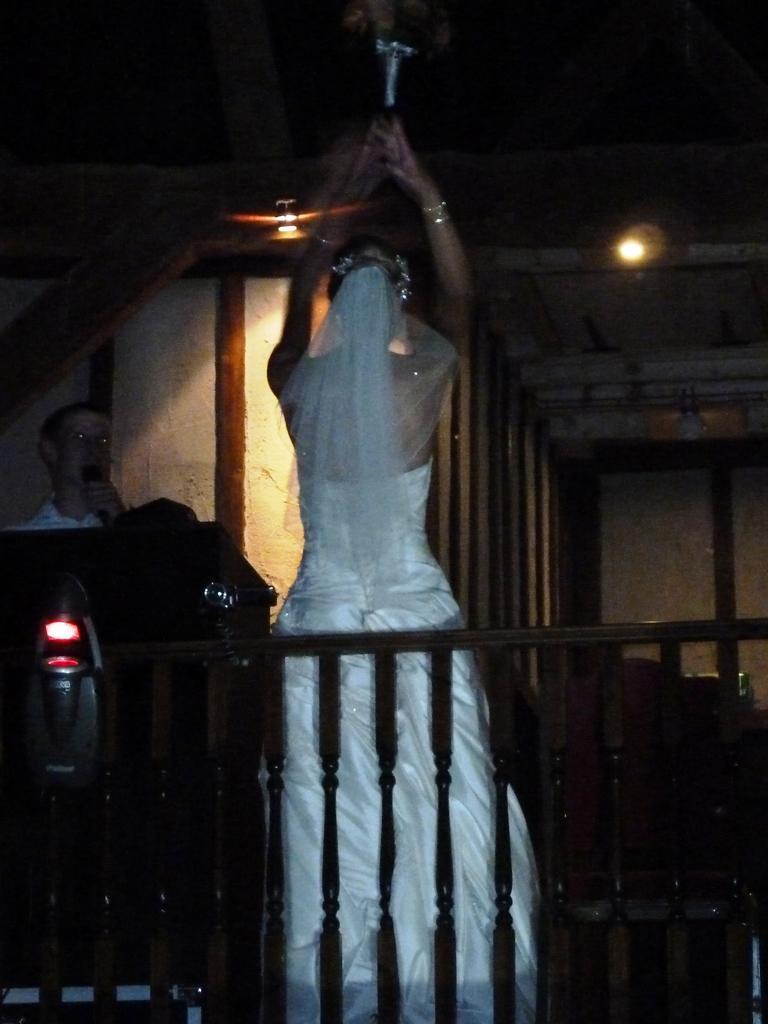Describe this image in one or two sentences. In this image we can see there is a bride standing in the middle of room, behind that there is a man speaking in the micro phone. 